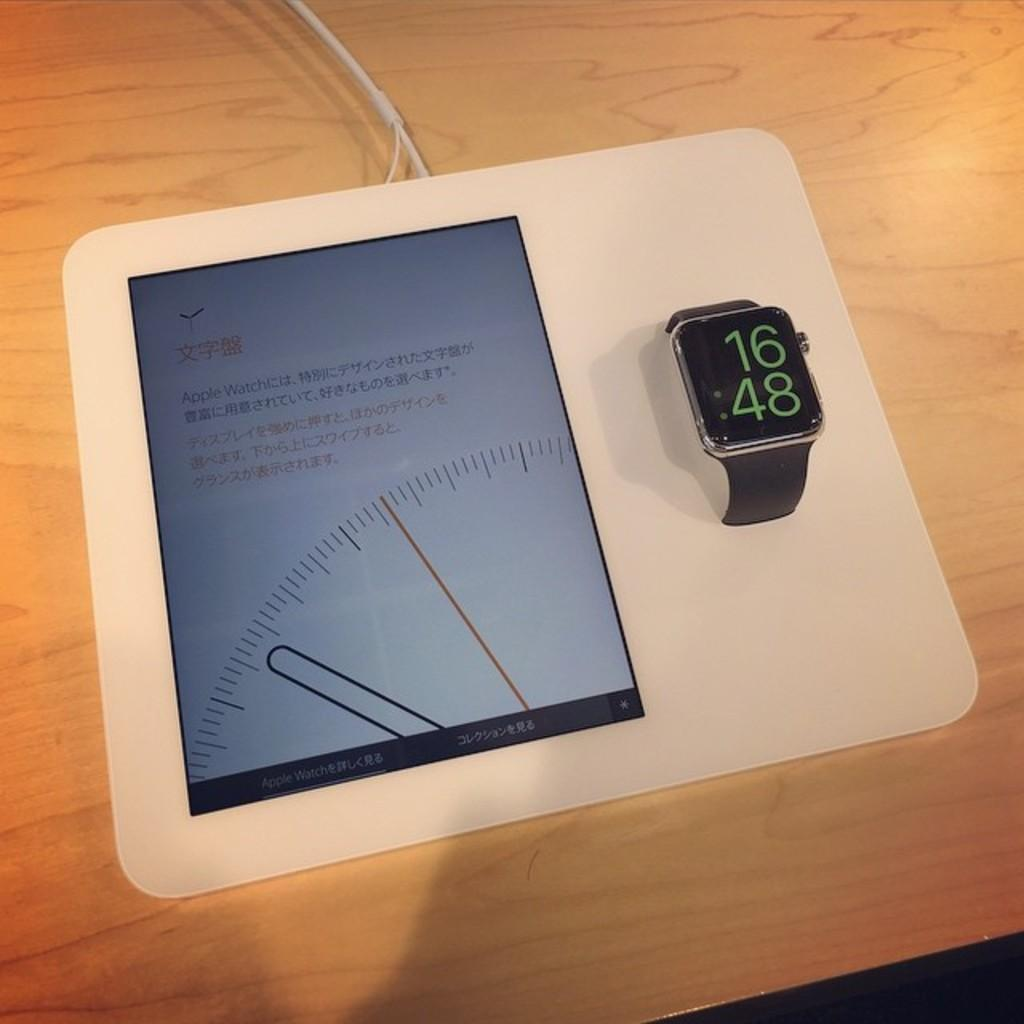<image>
Relay a brief, clear account of the picture shown. Black and green Apple watch on display of a touch screen tablet 